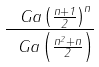<formula> <loc_0><loc_0><loc_500><loc_500>\frac { \ G a \left ( \frac { n + 1 } { 2 } \right ) ^ { n } } { \ G a \left ( \frac { n ^ { 2 } + n } { 2 } \right ) }</formula> 